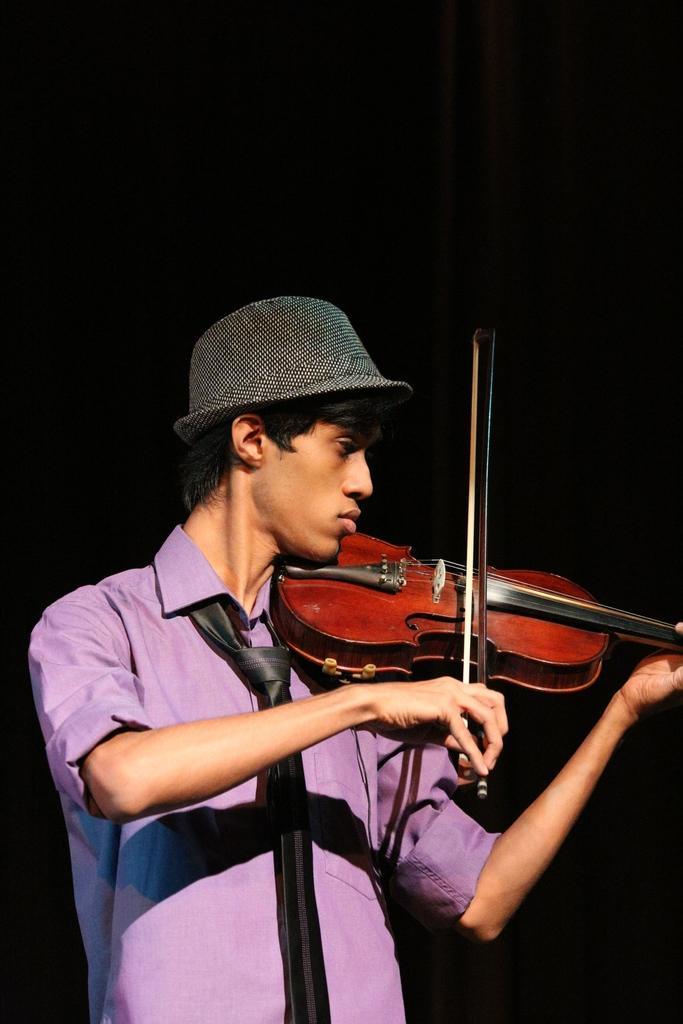Could you give a brief overview of what you see in this image? In this image I can see a person wearing the hat and playing the violin. 